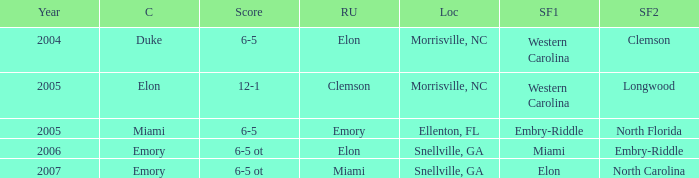How many teams were listed as runner up in 2005 and there the first semi finalist was Western Carolina? 1.0. 